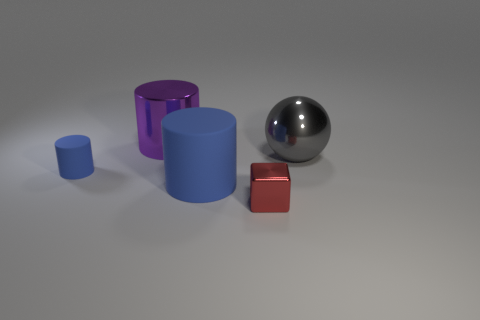Add 2 small brown spheres. How many objects exist? 7 Subtract all spheres. How many objects are left? 4 Add 5 metal objects. How many metal objects exist? 8 Subtract 0 green blocks. How many objects are left? 5 Subtract all small blue rubber objects. Subtract all blue shiny blocks. How many objects are left? 4 Add 2 large purple shiny cylinders. How many large purple shiny cylinders are left? 3 